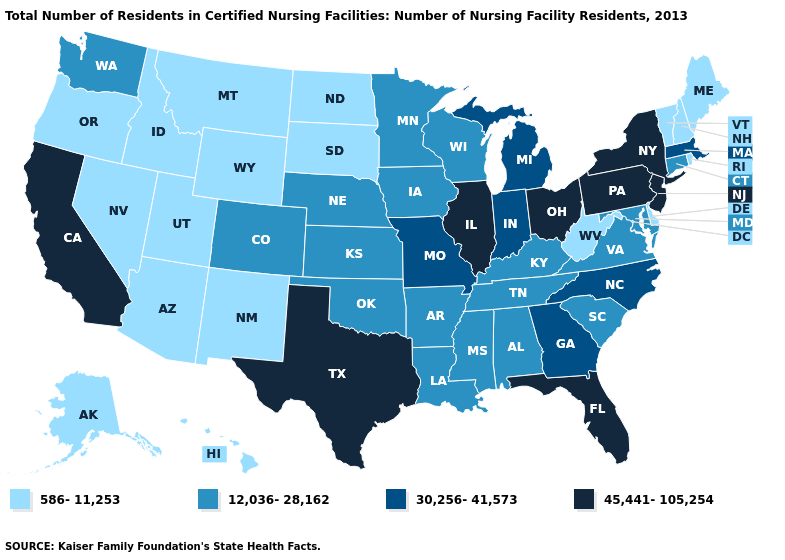Does New Jersey have the lowest value in the USA?
Give a very brief answer. No. Among the states that border Oregon , which have the highest value?
Quick response, please. California. Does Kansas have a lower value than Massachusetts?
Answer briefly. Yes. Name the states that have a value in the range 586-11,253?
Quick response, please. Alaska, Arizona, Delaware, Hawaii, Idaho, Maine, Montana, Nevada, New Hampshire, New Mexico, North Dakota, Oregon, Rhode Island, South Dakota, Utah, Vermont, West Virginia, Wyoming. Name the states that have a value in the range 45,441-105,254?
Keep it brief. California, Florida, Illinois, New Jersey, New York, Ohio, Pennsylvania, Texas. Among the states that border Washington , which have the lowest value?
Quick response, please. Idaho, Oregon. Does Colorado have a lower value than Idaho?
Quick response, please. No. What is the highest value in states that border Georgia?
Write a very short answer. 45,441-105,254. Which states have the lowest value in the MidWest?
Answer briefly. North Dakota, South Dakota. Which states have the highest value in the USA?
Quick response, please. California, Florida, Illinois, New Jersey, New York, Ohio, Pennsylvania, Texas. Name the states that have a value in the range 45,441-105,254?
Give a very brief answer. California, Florida, Illinois, New Jersey, New York, Ohio, Pennsylvania, Texas. Among the states that border Washington , which have the lowest value?
Keep it brief. Idaho, Oregon. Does California have the highest value in the West?
Concise answer only. Yes. What is the value of North Carolina?
Quick response, please. 30,256-41,573. Name the states that have a value in the range 12,036-28,162?
Answer briefly. Alabama, Arkansas, Colorado, Connecticut, Iowa, Kansas, Kentucky, Louisiana, Maryland, Minnesota, Mississippi, Nebraska, Oklahoma, South Carolina, Tennessee, Virginia, Washington, Wisconsin. 